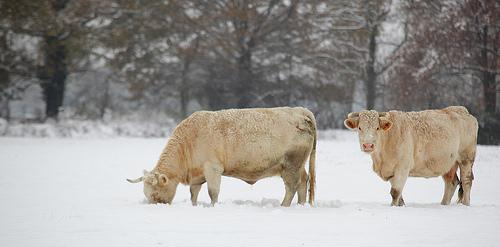Question: what is the bulls' color?
Choices:
A. Black.
B. Brown.
C. White.
D. Beige.
Answer with the letter. Answer: D Question: where they are?
Choices:
A. On the farm.
B. Lost for good.
C. In the snow.
D. In a tree.
Answer with the letter. Answer: C Question: where this picture was taken?
Choices:
A. On a lake.
B. In the woods.
C. On a tractor.
D. In a could place.
Answer with the letter. Answer: D 